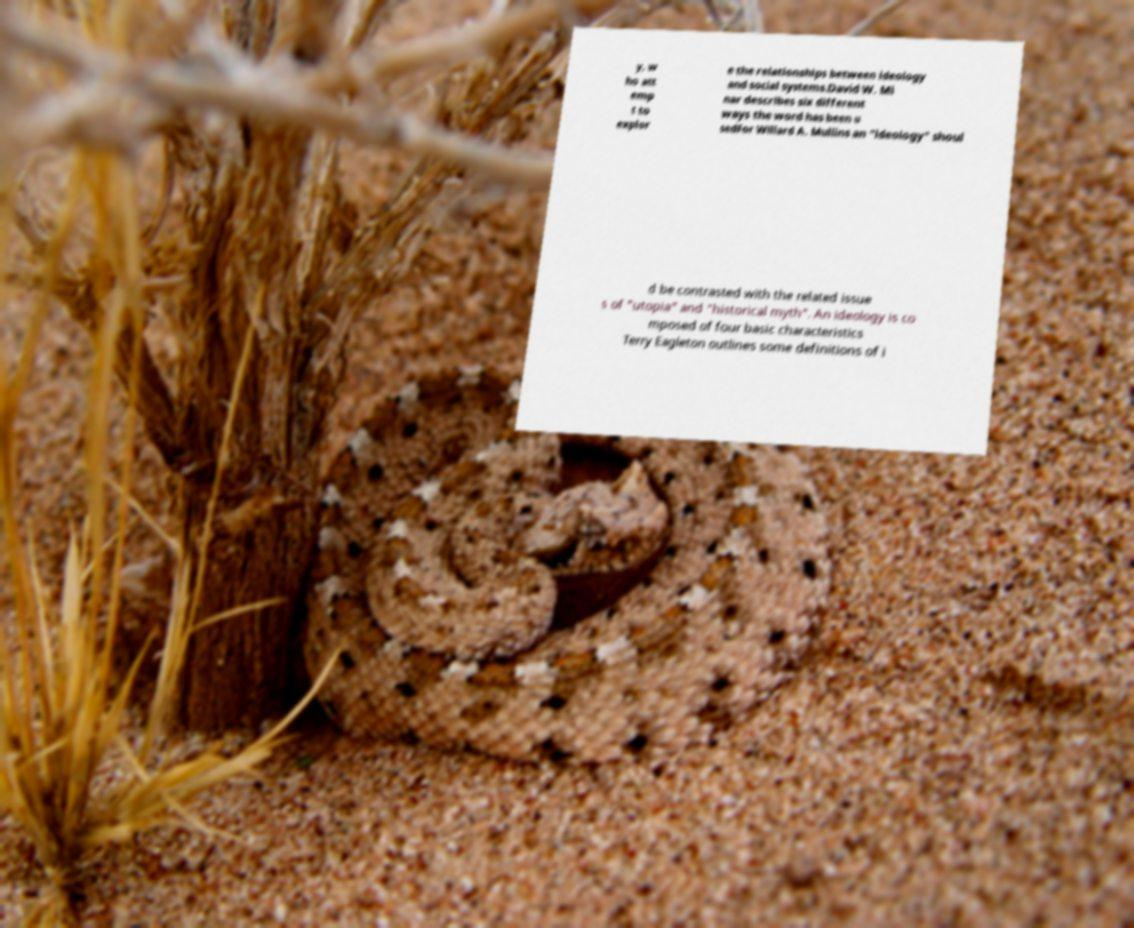Can you read and provide the text displayed in the image?This photo seems to have some interesting text. Can you extract and type it out for me? y, w ho att emp t to explor e the relationships between ideology and social systems.David W. Mi nar describes six different ways the word has been u sedFor Willard A. Mullins an "ideology" shoul d be contrasted with the related issue s of "utopia" and "historical myth". An ideology is co mposed of four basic characteristics Terry Eagleton outlines some definitions of i 